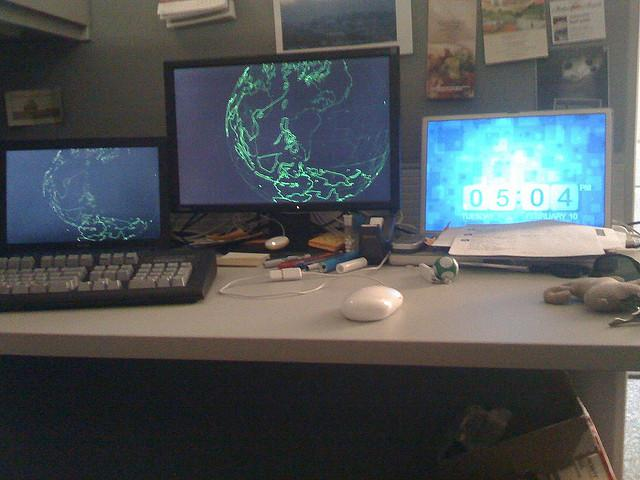What does the white mouse on the table do? Please explain your reasoning. control computers. The mouse controls computers. 